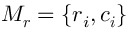Convert formula to latex. <formula><loc_0><loc_0><loc_500><loc_500>M _ { r } = \{ r _ { i } , c _ { i } \}</formula> 